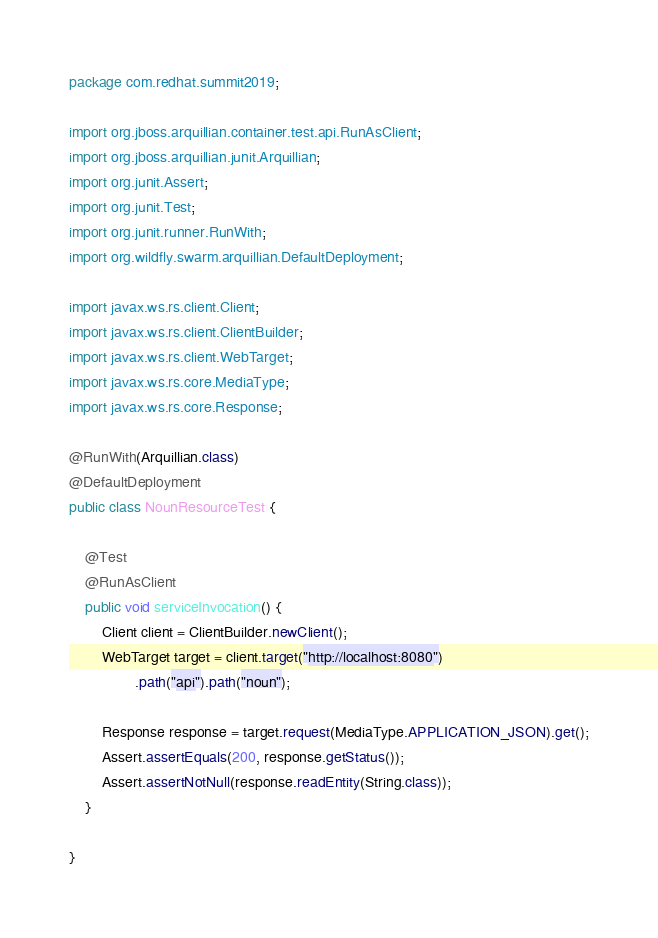<code> <loc_0><loc_0><loc_500><loc_500><_Java_>package com.redhat.summit2019;

import org.jboss.arquillian.container.test.api.RunAsClient;
import org.jboss.arquillian.junit.Arquillian;
import org.junit.Assert;
import org.junit.Test;
import org.junit.runner.RunWith;
import org.wildfly.swarm.arquillian.DefaultDeployment;

import javax.ws.rs.client.Client;
import javax.ws.rs.client.ClientBuilder;
import javax.ws.rs.client.WebTarget;
import javax.ws.rs.core.MediaType;
import javax.ws.rs.core.Response;

@RunWith(Arquillian.class)
@DefaultDeployment
public class NounResourceTest {

    @Test
    @RunAsClient
    public void serviceInvocation() {
        Client client = ClientBuilder.newClient();
        WebTarget target = client.target("http://localhost:8080")
                .path("api").path("noun");

        Response response = target.request(MediaType.APPLICATION_JSON).get();
        Assert.assertEquals(200, response.getStatus());
        Assert.assertNotNull(response.readEntity(String.class));
    }

}</code> 